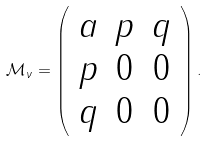<formula> <loc_0><loc_0><loc_500><loc_500>\mathcal { M } _ { \nu } = \left ( \begin{array} { c c c } a & p & q \\ p & 0 & 0 \\ q & 0 & 0 \end{array} \right ) .</formula> 